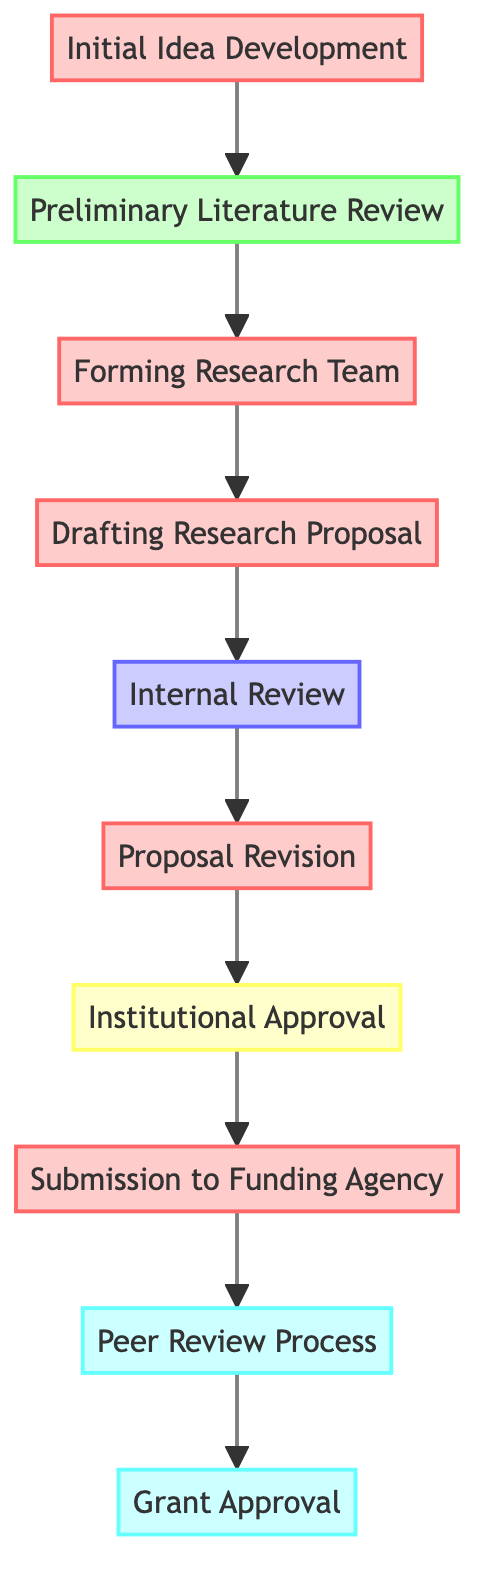What is the first step in the grant proposal submission process? The first step in the process, indicated at the bottom of the flow chart, is "Initial Idea Development."
Answer: Initial Idea Development Who is responsible for drafting the research proposal? In the flow chart, the "Drafting Research Proposal" node is attributed to the "Principal Investigator" as the responsible party.
Answer: Principal Investigator How many steps are there in the proposal submission process? Counting the nodes in the diagram from "Initial Idea Development" to "Grant Approval," there are a total of 10 steps in the process.
Answer: 10 What step follows the "Internal Review"? According to the flow of the diagram, "Proposal Revision" follows the "Internal Review" node.
Answer: Proposal Revision Which step involves obtaining university approval? The step that involves obtaining approval from the university’s research office is labeled "Institutional Approval" in the diagram.
Answer: Institutional Approval What is the last step before receiving grant approval? The last step before "Grant Approval" is "Peer Review Process," where the proposal awaits evaluation from external reviewers.
Answer: Peer Review Process Which two steps are directly conducted by the Principal Investigator? The Principal Investigator is responsible for both "Drafting Research Proposal" and "Submission to Funding Agency" as indicated in the diagram.
Answer: Drafting Research Proposal, Submission to Funding Agency What type of review occurs after drafting the proposal? The type of review that occurs after the "Drafting Research Proposal" step is the "Internal Review," which evaluates the proposal within the department or college.
Answer: Internal Review Which element is the responsibility of the university's research office? "Institutional Approval" is the element that the university's research office is responsible for, as specified in the flowchart.
Answer: Institutional Approval 